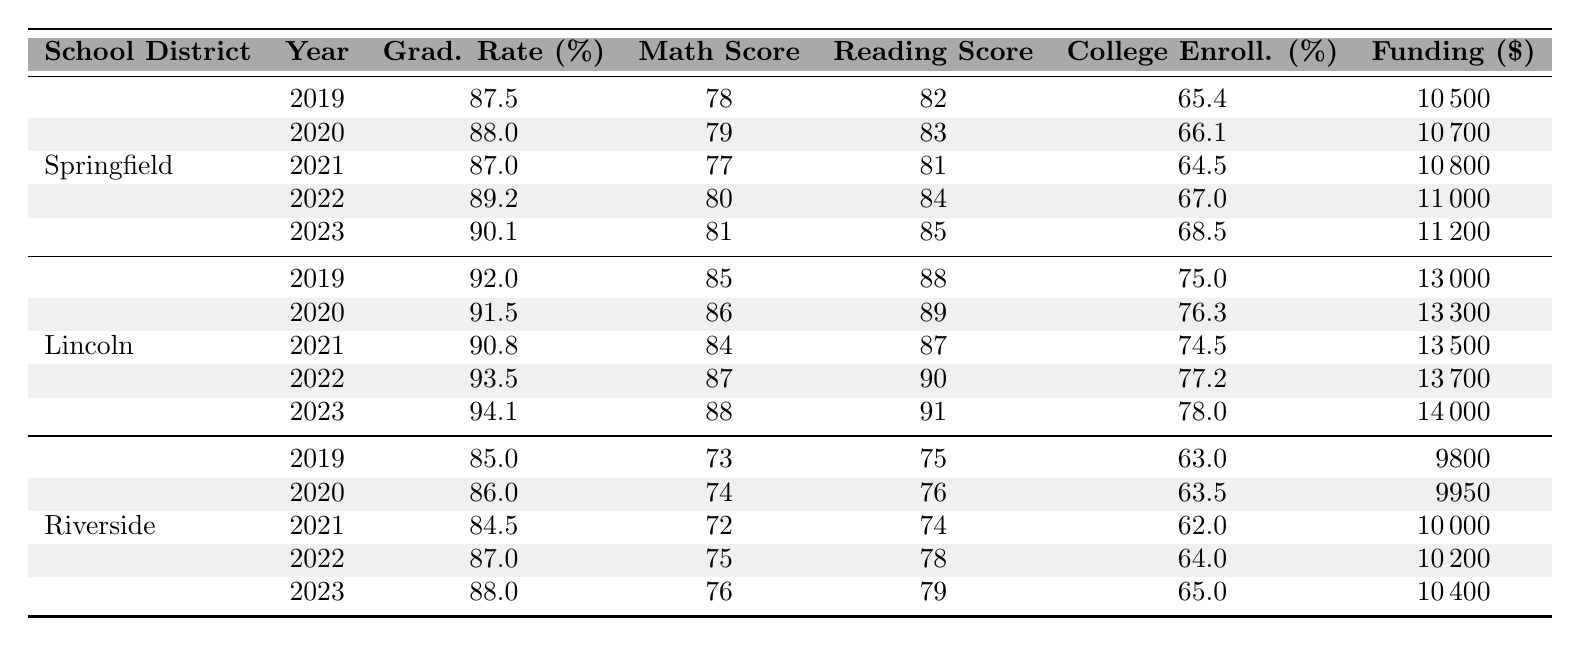What was the graduation rate for Lincoln School District in 2022? From the table, under Lincoln School District for the year 2022, the graduation rate is listed as 93.5%.
Answer: 93.5 Which school district had the highest funding per student in 2023? Looking at the 2023 row, Lincoln School District has the highest funding per student at $14,000, compared to Springfield's $11,200 and Riverside's $10,400.
Answer: Lincoln School District What is the average math score for Riverside School District over the five years? The math scores for Riverside from 2019 to 2023 are 73, 74, 72, 75, and 76. Summing these scores gives 370, and dividing by 5 (the number of years) results in an average of 74.
Answer: 74 Did the college enrollment rate for Springfield School District improve from 2019 to 2023? The college enrollment rates for Springfield in 2019 and 2023 are 65.4% and 68.5%, respectively. Since 68.5% is greater than 65.4%, it indicates an improvement.
Answer: Yes What is the change in graduation rate for Riverside School District from 2019 to 2023? The graduation rate in 2019 is 85.0%, and in 2023 it is 88.0%. The change is calculated by subtracting the earlier rate from the later rate: 88.0% - 85.0% = 3.0%.
Answer: 3.0 Which year saw the highest average funding per student across all districts? Analyzing the data for 2019 through 2023, the funding per student is as follows: 2019: $10,500, 2020: $10,700, 2021: $10,800, 2022: $11,000, and 2023: $14,000. The highest among these is 2023 at $14,000.
Answer: 2023 What is the difference in reading scores between Lincoln and Riverside School Districts in 2021? The reading score for Lincoln in 2021 is 87, while Riverside's is 74. The difference is calculated as 87 - 74 = 13.
Answer: 13 Overall, how did the funding per student trend for Springfield School District over the five years? Springfield's funding per student over the years shows an increase: $10,500 in 2019 to $11,200 in 2023. This constitutes a steady positive trend of increasing funding.
Answer: Increasing Is there a correlation between increased funding and graduation rates within Lincoln School District? In Lincoln, funding increased from $13,000 in 2019 to $14,000 in 2023, while the graduation rate rose from 92% to 94.1%. This suggests a potential positive correlation, as both metrics increased.
Answer: Yes How did the college enrollment rate in Riverside School District fluctuate from 2019 to 2023? The rates are as follows: 2019: 63.0%, 2020: 63.5%, 2021: 62.0%, 2022: 64.0%, 2023: 65.0%. The rates show slight fluctuations but overall there is an increase from 63.0% to 65.0%.
Answer: Increased 